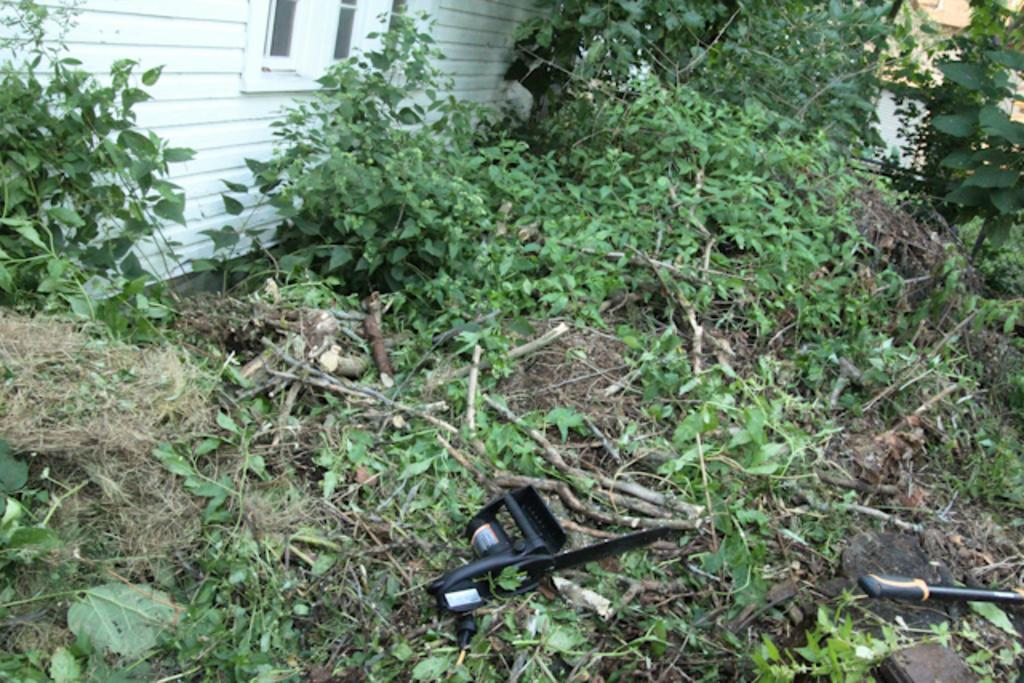What is located at the top of the image? There is a wall at the top of the image. What can be seen in the image that allows light to enter? There is a window in the image. What type of vegetation is present in the image? There are plants in the image. What type of plants are visible in the image? There are creeps in the plants in the image. What type of ground surface is visible in the image? There is grass in the image. What type of objects are present in the image that are used for support or construction? There are sticks in the image. What other objects can be seen in the middle of the image? There are other objects visible in the middle of the image. What type of juice can be seen being poured from a pail in the image? There is no pail or juice present in the image. In which bedroom is the image taken? The image does not depict a bedroom, so it cannot be determined which bedroom it is taken in. 